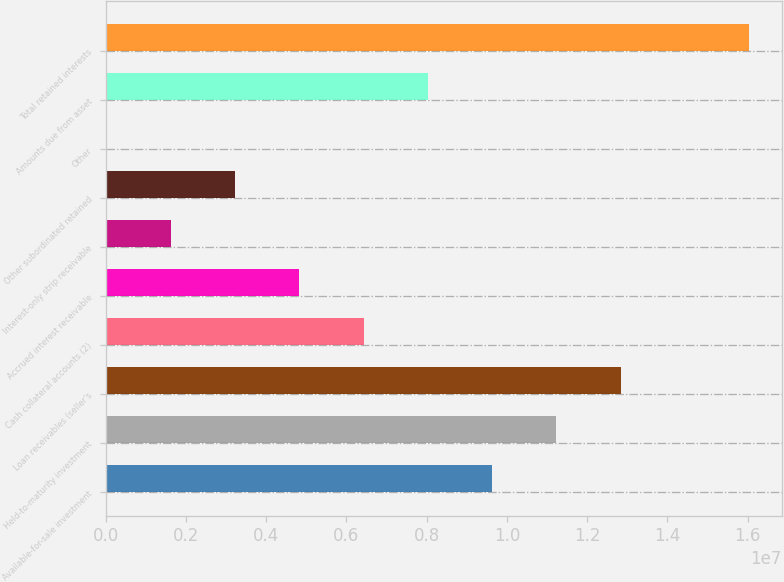Convert chart. <chart><loc_0><loc_0><loc_500><loc_500><bar_chart><fcel>Available-for-sale investment<fcel>Held-to-maturity investment<fcel>Loan receivables (seller's<fcel>Cash collateral accounts (2)<fcel>Accrued interest receivable<fcel>Interest-only strip receivable<fcel>Other subordinated retained<fcel>Other<fcel>Amounts due from asset<fcel>Total retained interests<nl><fcel>9.63224e+06<fcel>1.12356e+07<fcel>1.28389e+07<fcel>6.4256e+06<fcel>4.82228e+06<fcel>1.61564e+06<fcel>3.21896e+06<fcel>12324<fcel>8.02892e+06<fcel>1.60455e+07<nl></chart> 